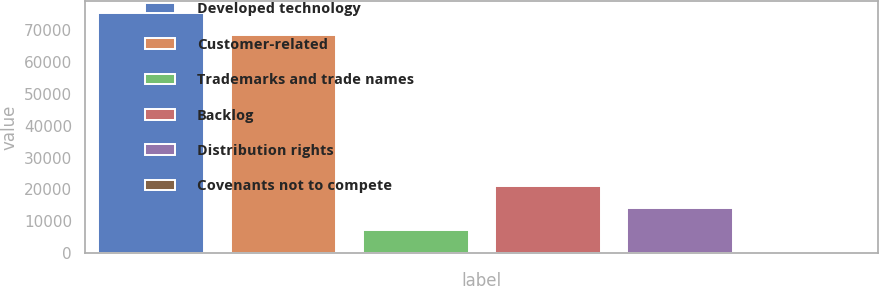<chart> <loc_0><loc_0><loc_500><loc_500><bar_chart><fcel>Developed technology<fcel>Customer-related<fcel>Trademarks and trade names<fcel>Backlog<fcel>Distribution rights<fcel>Covenants not to compete<nl><fcel>75399.4<fcel>68522<fcel>7210.4<fcel>20965.2<fcel>14087.8<fcel>333<nl></chart> 